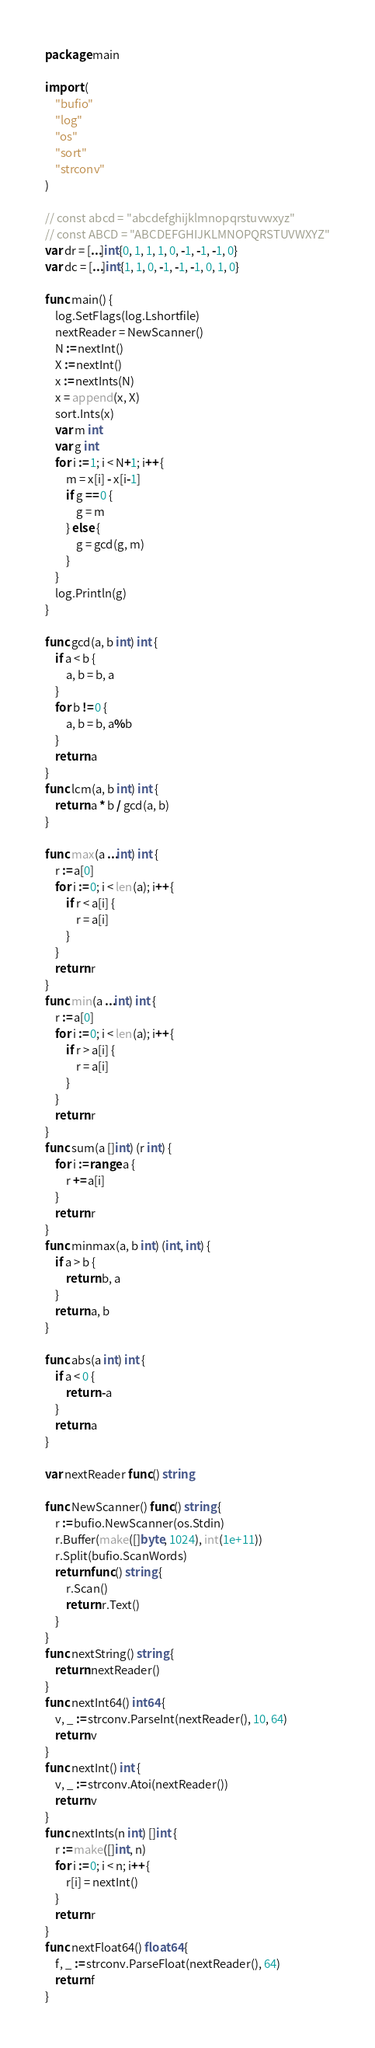Convert code to text. <code><loc_0><loc_0><loc_500><loc_500><_Go_>package main

import (
	"bufio"
	"log"
	"os"
	"sort"
	"strconv"
)

// const abcd = "abcdefghijklmnopqrstuvwxyz"
// const ABCD = "ABCDEFGHIJKLMNOPQRSTUVWXYZ"
var dr = [...]int{0, 1, 1, 1, 0, -1, -1, -1, 0}
var dc = [...]int{1, 1, 0, -1, -1, -1, 0, 1, 0}

func main() {
	log.SetFlags(log.Lshortfile)
	nextReader = NewScanner()
	N := nextInt()
	X := nextInt()
	x := nextInts(N)
	x = append(x, X)
	sort.Ints(x)
	var m int
	var g int
	for i := 1; i < N+1; i++ {
		m = x[i] - x[i-1]
		if g == 0 {
			g = m
		} else {
			g = gcd(g, m)
		}
	}
	log.Println(g)
}

func gcd(a, b int) int {
	if a < b {
		a, b = b, a
	}
	for b != 0 {
		a, b = b, a%b
	}
	return a
}
func lcm(a, b int) int {
	return a * b / gcd(a, b)
}

func max(a ...int) int {
	r := a[0]
	for i := 0; i < len(a); i++ {
		if r < a[i] {
			r = a[i]
		}
	}
	return r
}
func min(a ...int) int {
	r := a[0]
	for i := 0; i < len(a); i++ {
		if r > a[i] {
			r = a[i]
		}
	}
	return r
}
func sum(a []int) (r int) {
	for i := range a {
		r += a[i]
	}
	return r
}
func minmax(a, b int) (int, int) {
	if a > b {
		return b, a
	}
	return a, b
}

func abs(a int) int {
	if a < 0 {
		return -a
	}
	return a
}

var nextReader func() string

func NewScanner() func() string {
	r := bufio.NewScanner(os.Stdin)
	r.Buffer(make([]byte, 1024), int(1e+11))
	r.Split(bufio.ScanWords)
	return func() string {
		r.Scan()
		return r.Text()
	}
}
func nextString() string {
	return nextReader()
}
func nextInt64() int64 {
	v, _ := strconv.ParseInt(nextReader(), 10, 64)
	return v
}
func nextInt() int {
	v, _ := strconv.Atoi(nextReader())
	return v
}
func nextInts(n int) []int {
	r := make([]int, n)
	for i := 0; i < n; i++ {
		r[i] = nextInt()
	}
	return r
}
func nextFloat64() float64 {
	f, _ := strconv.ParseFloat(nextReader(), 64)
	return f
}
</code> 